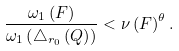Convert formula to latex. <formula><loc_0><loc_0><loc_500><loc_500>\frac { \omega _ { 1 } \left ( F \right ) } { \omega _ { 1 } \left ( \triangle _ { r _ { 0 } } \left ( Q \right ) \right ) } < \nu \left ( F \right ) ^ { \theta } .</formula> 